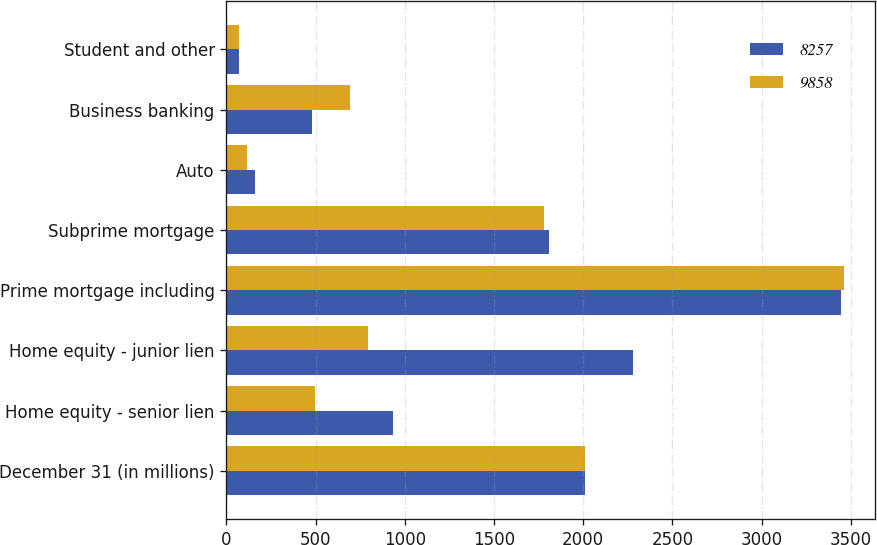Convert chart. <chart><loc_0><loc_0><loc_500><loc_500><stacked_bar_chart><ecel><fcel>December 31 (in millions)<fcel>Home equity - senior lien<fcel>Home equity - junior lien<fcel>Prime mortgage including<fcel>Subprime mortgage<fcel>Auto<fcel>Business banking<fcel>Student and other<nl><fcel>8257<fcel>2012<fcel>931<fcel>2277<fcel>3445<fcel>1807<fcel>163<fcel>481<fcel>70<nl><fcel>9858<fcel>2011<fcel>495<fcel>792<fcel>3462<fcel>1781<fcel>118<fcel>694<fcel>69<nl></chart> 